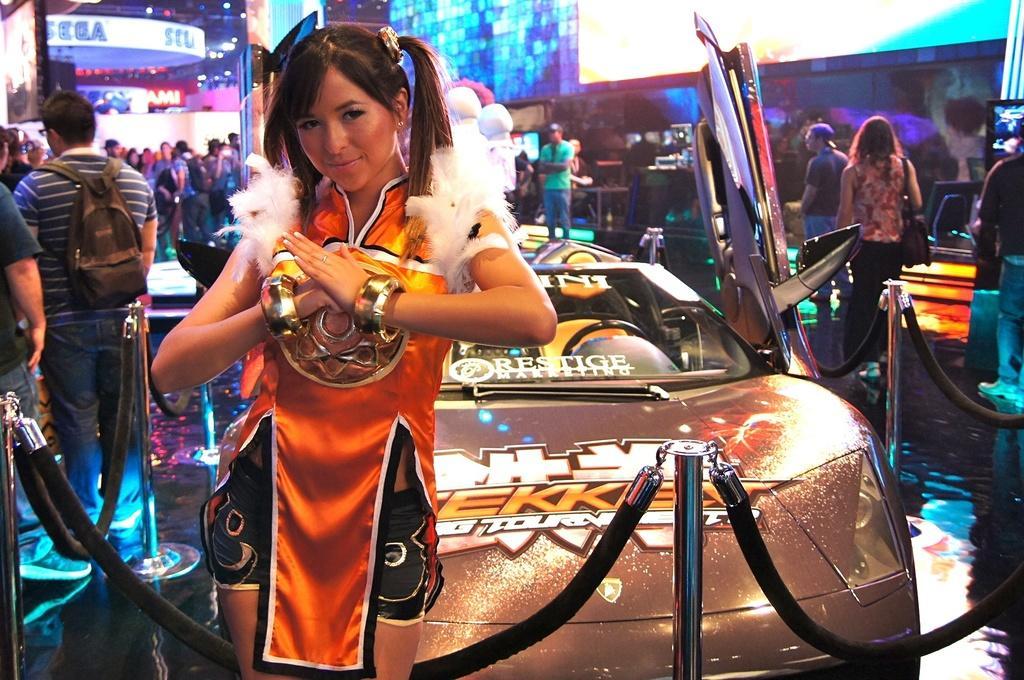In one or two sentences, can you explain what this image depicts? In the image there is a woman in orange dress standing in front of a car and there are many people walking on either side and in the background. 